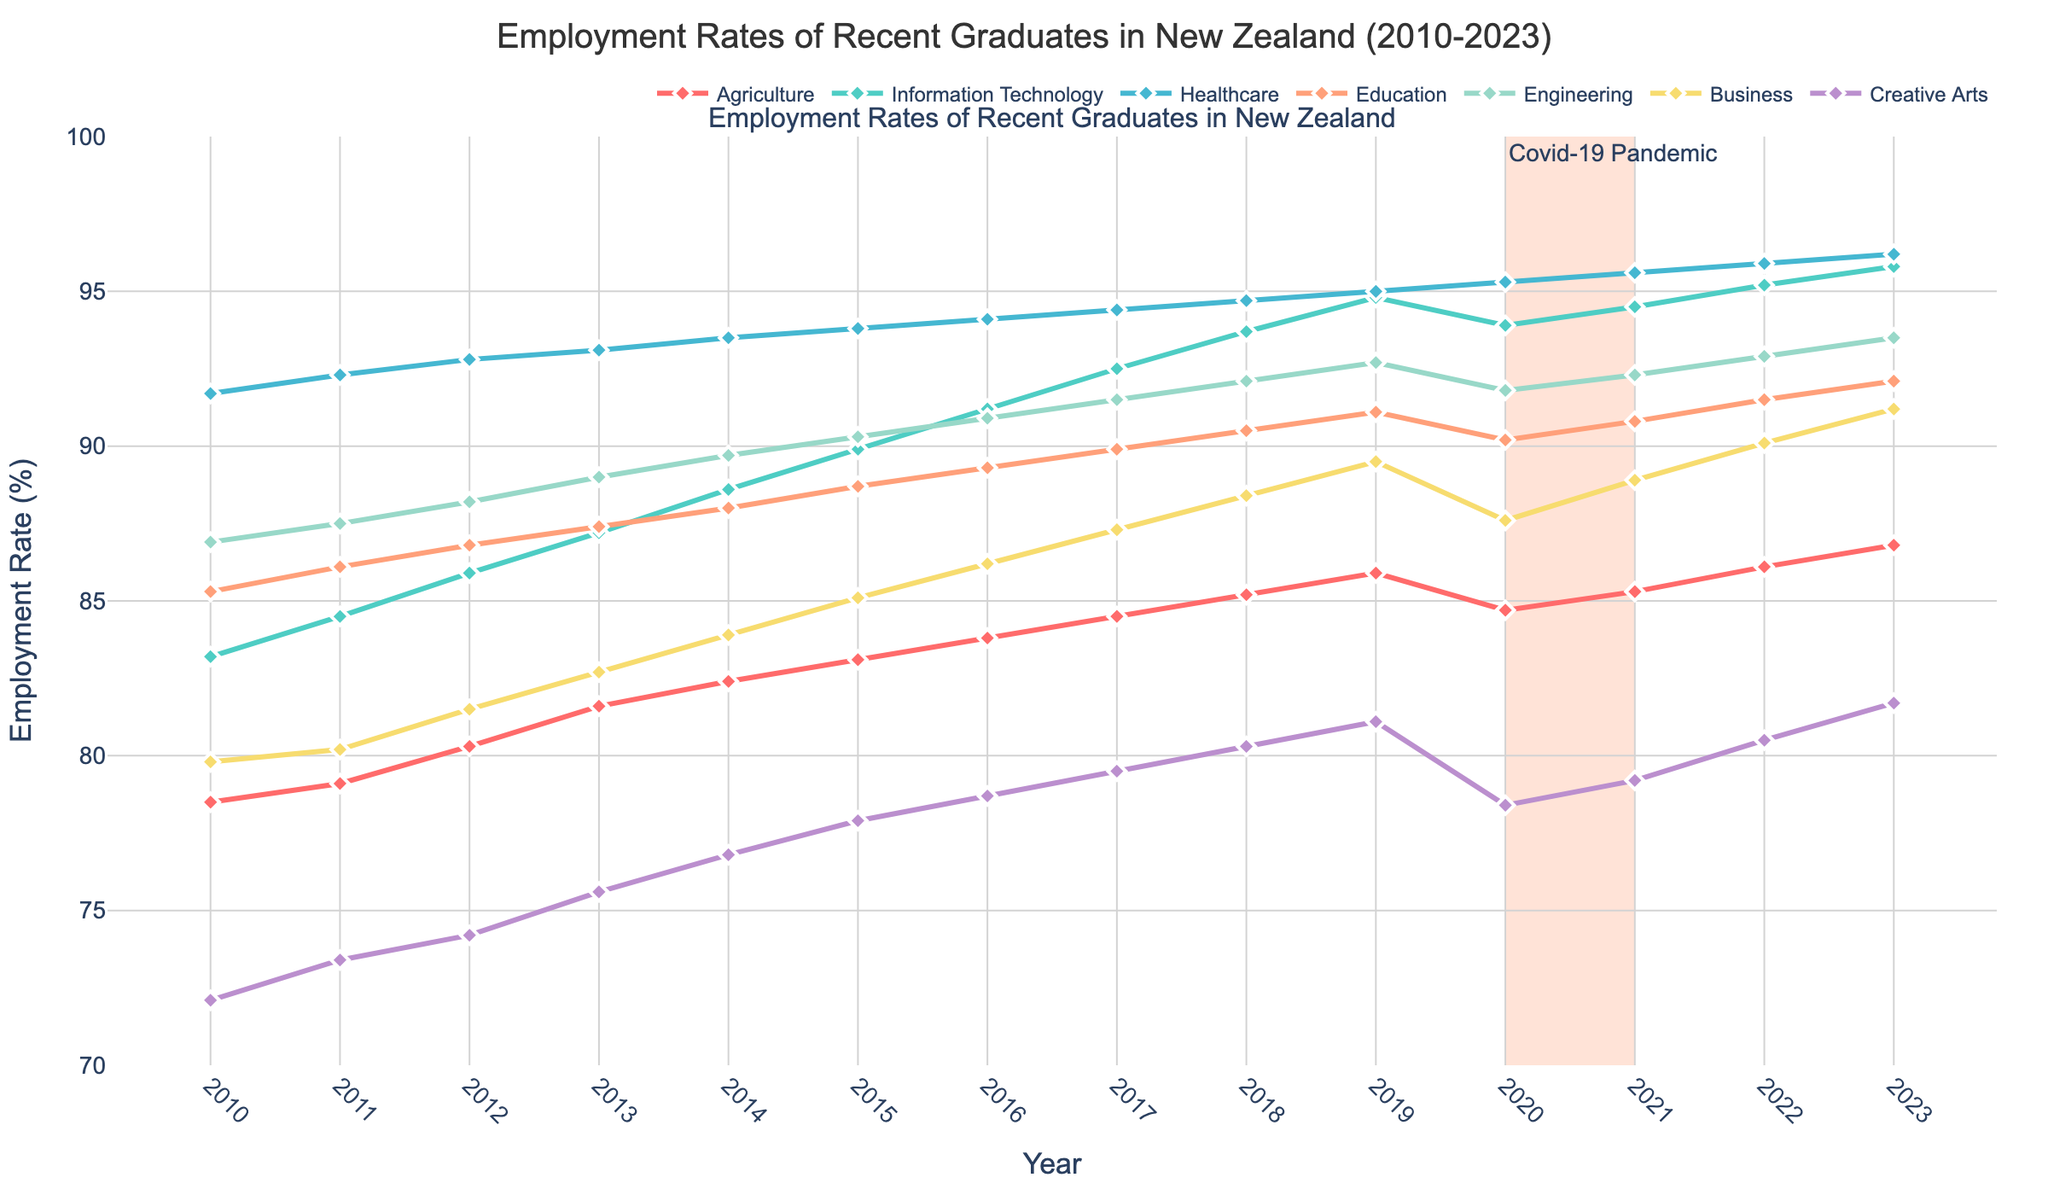Which industry had the highest employment rate in 2010? Look at the 2010 data point for each industry and compare the heights of the markers on the y-axis to see which one is the highest. Healthcare has the highest employment rate at around 91.7%.
Answer: Healthcare Which industry showed the most significant increase in employment rate from 2010 to 2023? Calculate the difference for each industry between 2023 and 2010, then find the industry with the highest increase. For instance, Information Technology went from 83.2% to 95.8%, a 12.6% increase. Information Technology has the most significant increase.
Answer: Information Technology During the Covid-19 pandemic period (2020-2021), did any industry see a drop in employment rates? Visually inspect the employment rates from 2020 to 2021. Look for any downward trends in this period. The Creative Arts industry saw a decrease from 81.1% to 78.4%.
Answer: Creative Arts On average, how much did the employment rate change per year for Business from 2010 to 2023? Sum the employment rate changes per year for the Business industry and divide by the number of years (2023-2010=13 years). The total change is 91.2% - 79.8% = 11.4%. The average annual change is 11.4% / 13 ≈ 0.88%.
Answer: Approximately 0.88% Which industry had the smallest variance in employment rates from 2010 to 2023? Examine the employment rates for each industry over the years and visually assess the stability of the lines. Healthcare has the smallest variance as its employment rate remains relatively stable and high throughout the years.
Answer: Healthcare Did any industry have an employment rate below 80% at any point during the given period? Check each industry's employment rates over the years to see if they ever fall below 80%. Creative Arts had an employment rate starting at 72.1% in 2010 and went above 80% only after 2018.
Answer: Creative Arts What is the average employment rate of the Engineering industry from 2010 to 2023? Sum up the employment rates of the Engineering industry from 2010 to 2023 and divide by the number of years (14 years). So, (86.9 + 87.5 + 88.2 + 89.0 + 89.7 + 90.3 + 90.9 + 91.5 + 92.1 + 92.7 + 91.8 + 92.3 + 92.9 + 93.5) / 14 = 90.59.
Answer: Approximately 90.59% Between Information Technology and Business, which had a higher employment rate in 2015? Compare the 2015 data points for both Information Technology and Business. Information Technology had an employment rate of 89.9%, while Business had 85.1%. Therefore, Information Technology was higher.
Answer: Information Technology Which industry's employment rate remained consistently above 90% from 2010 to 2023? Identify the industries with data points all above 90% throughout the given period. Healthcare's employment rate consistently stayed above 90% from 2010 to 2023.
Answer: Healthcare By how much did the employment rate in Education change from 2013 to 2018? Subtract the employment rate in 2013 for Education from the rate in 2018. The employment rate in 2018 is 90.5% and in 2013 is 87.4%, the change is 90.5% - 87.4% = 3.1%.
Answer: 3.1% 